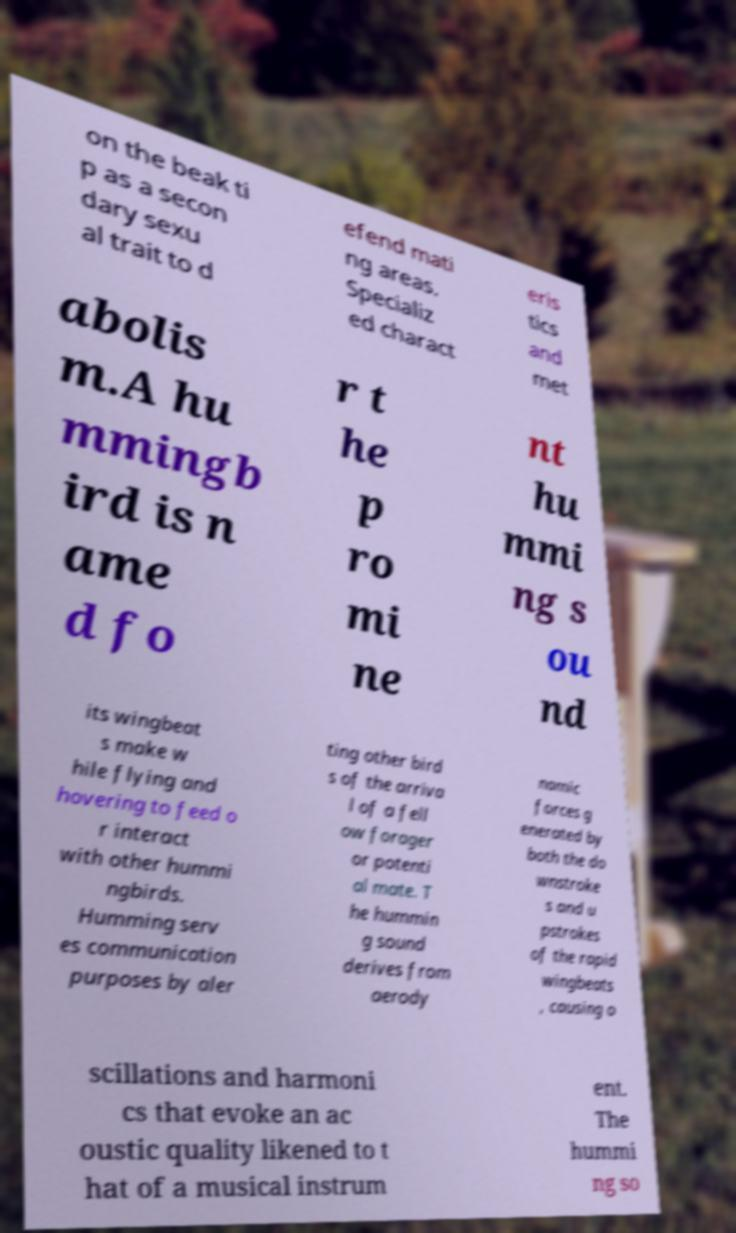Please identify and transcribe the text found in this image. on the beak ti p as a secon dary sexu al trait to d efend mati ng areas. Specializ ed charact eris tics and met abolis m.A hu mmingb ird is n ame d fo r t he p ro mi ne nt hu mmi ng s ou nd its wingbeat s make w hile flying and hovering to feed o r interact with other hummi ngbirds. Humming serv es communication purposes by aler ting other bird s of the arriva l of a fell ow forager or potenti al mate. T he hummin g sound derives from aerody namic forces g enerated by both the do wnstroke s and u pstrokes of the rapid wingbeats , causing o scillations and harmoni cs that evoke an ac oustic quality likened to t hat of a musical instrum ent. The hummi ng so 